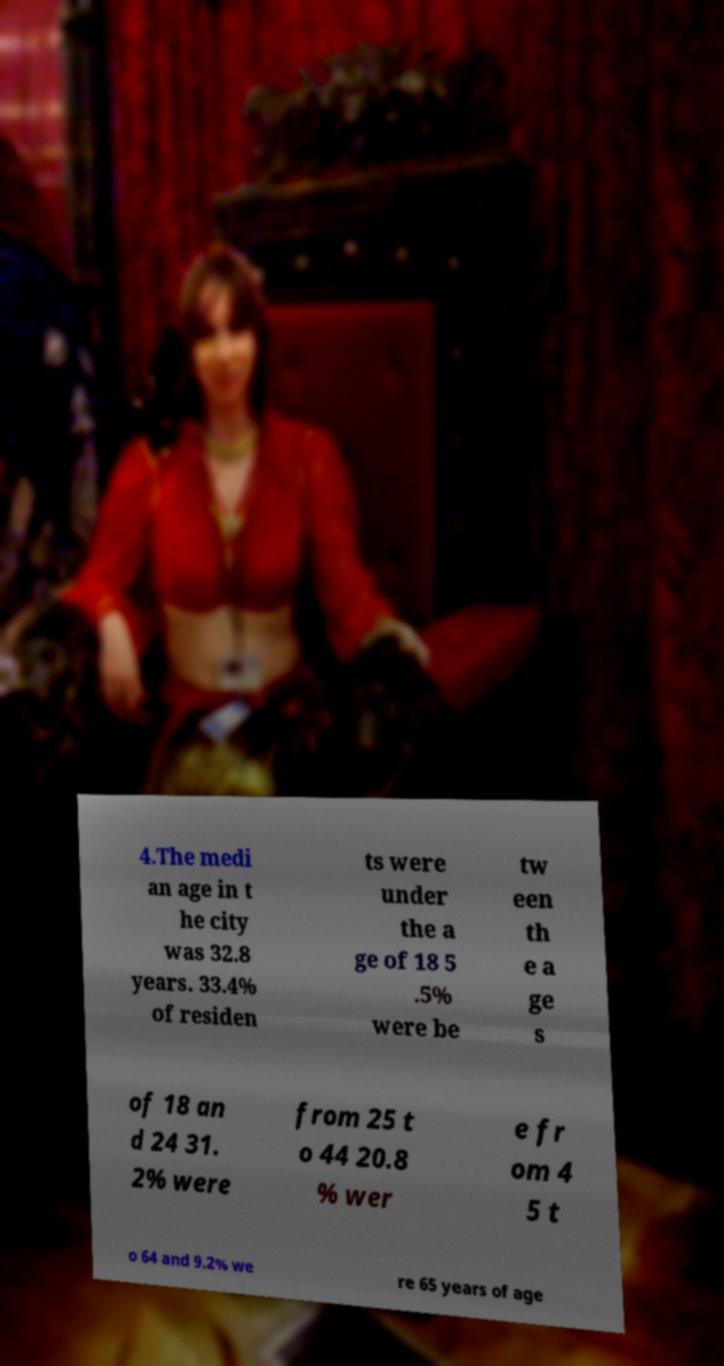Could you extract and type out the text from this image? 4.The medi an age in t he city was 32.8 years. 33.4% of residen ts were under the a ge of 18 5 .5% were be tw een th e a ge s of 18 an d 24 31. 2% were from 25 t o 44 20.8 % wer e fr om 4 5 t o 64 and 9.2% we re 65 years of age 